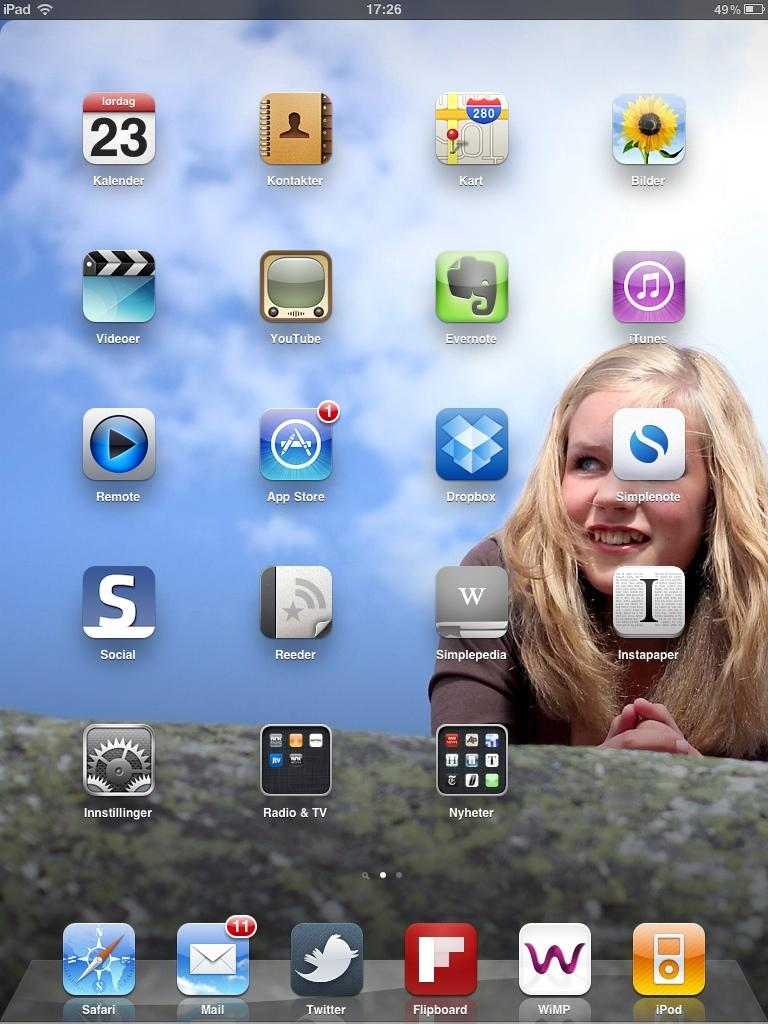<image>
Present a compact description of the photo's key features. A cellphone screen with apps such as Remote Social and Videoer on it. 